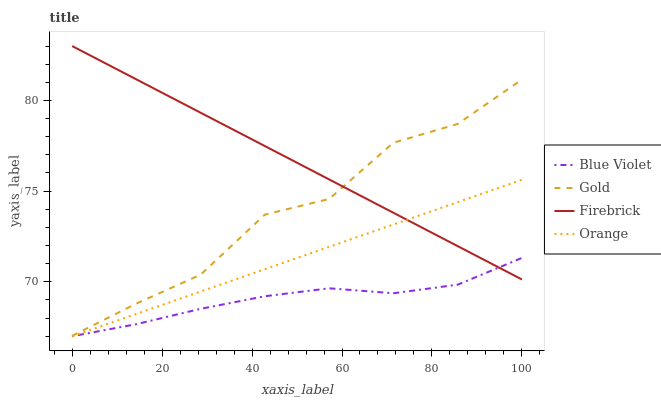Does Blue Violet have the minimum area under the curve?
Answer yes or no. Yes. Does Firebrick have the maximum area under the curve?
Answer yes or no. Yes. Does Gold have the minimum area under the curve?
Answer yes or no. No. Does Gold have the maximum area under the curve?
Answer yes or no. No. Is Firebrick the smoothest?
Answer yes or no. Yes. Is Gold the roughest?
Answer yes or no. Yes. Is Gold the smoothest?
Answer yes or no. No. Is Firebrick the roughest?
Answer yes or no. No. Does Gold have the lowest value?
Answer yes or no. No. Does Gold have the highest value?
Answer yes or no. No. Is Orange less than Gold?
Answer yes or no. Yes. Is Gold greater than Orange?
Answer yes or no. Yes. Does Orange intersect Gold?
Answer yes or no. No. 